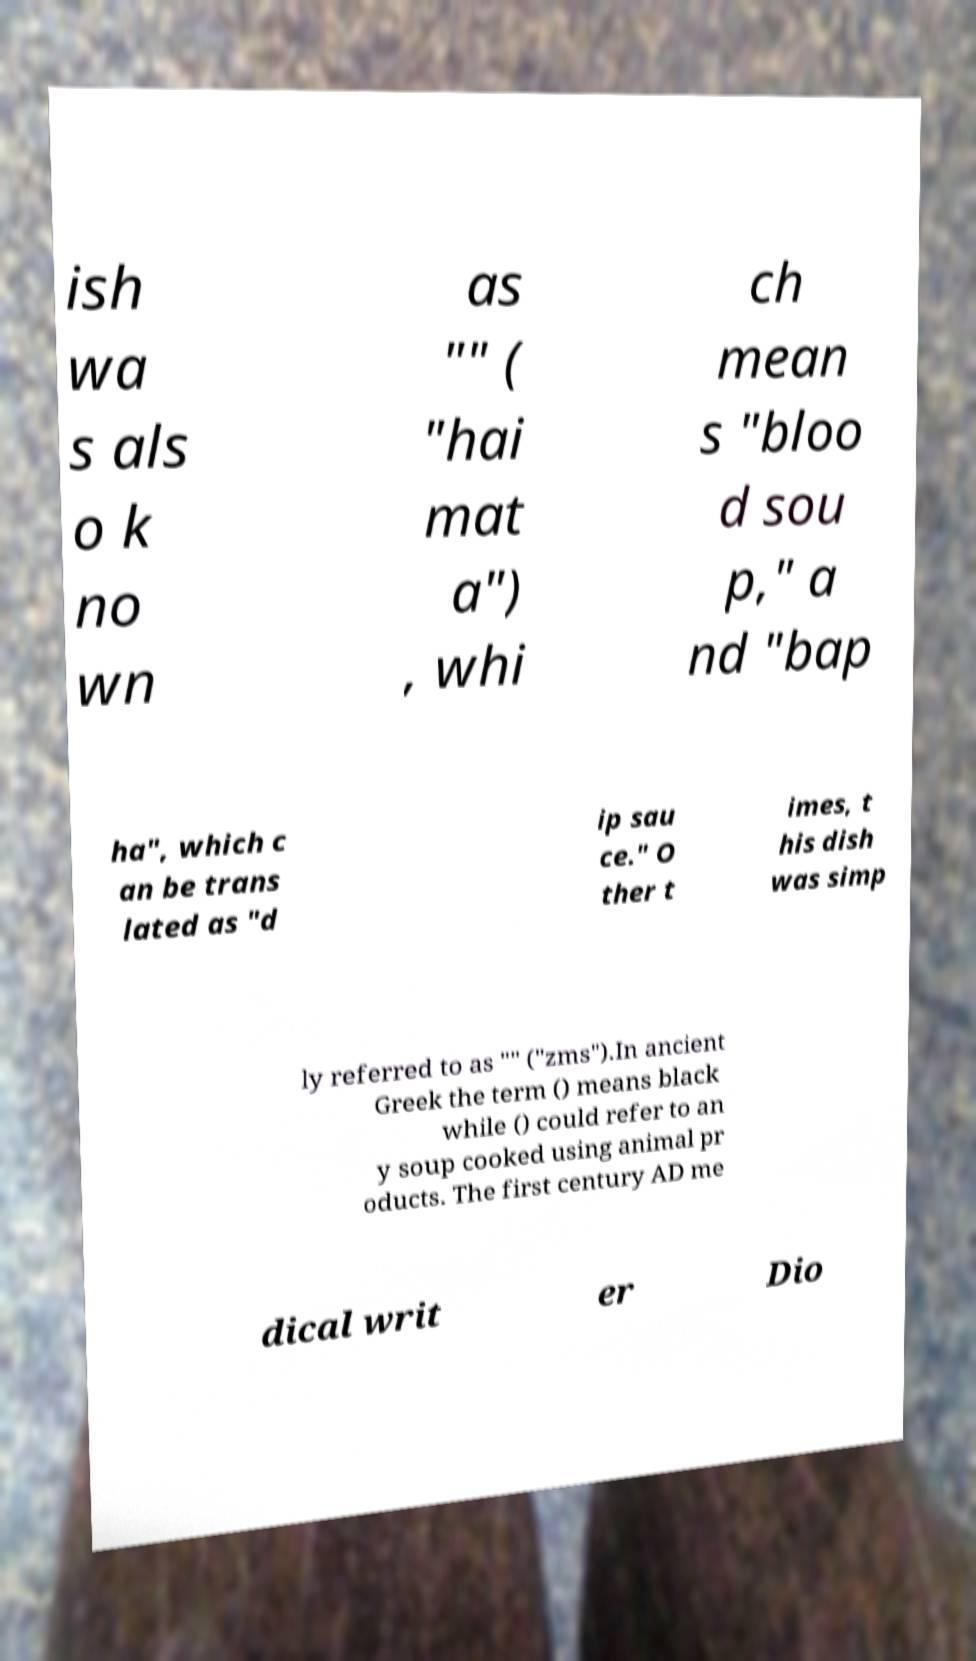Can you accurately transcribe the text from the provided image for me? ish wa s als o k no wn as "" ( "hai mat a") , whi ch mean s "bloo d sou p," a nd "bap ha", which c an be trans lated as "d ip sau ce." O ther t imes, t his dish was simp ly referred to as "" ("zms").In ancient Greek the term () means black while () could refer to an y soup cooked using animal pr oducts. The first century AD me dical writ er Dio 